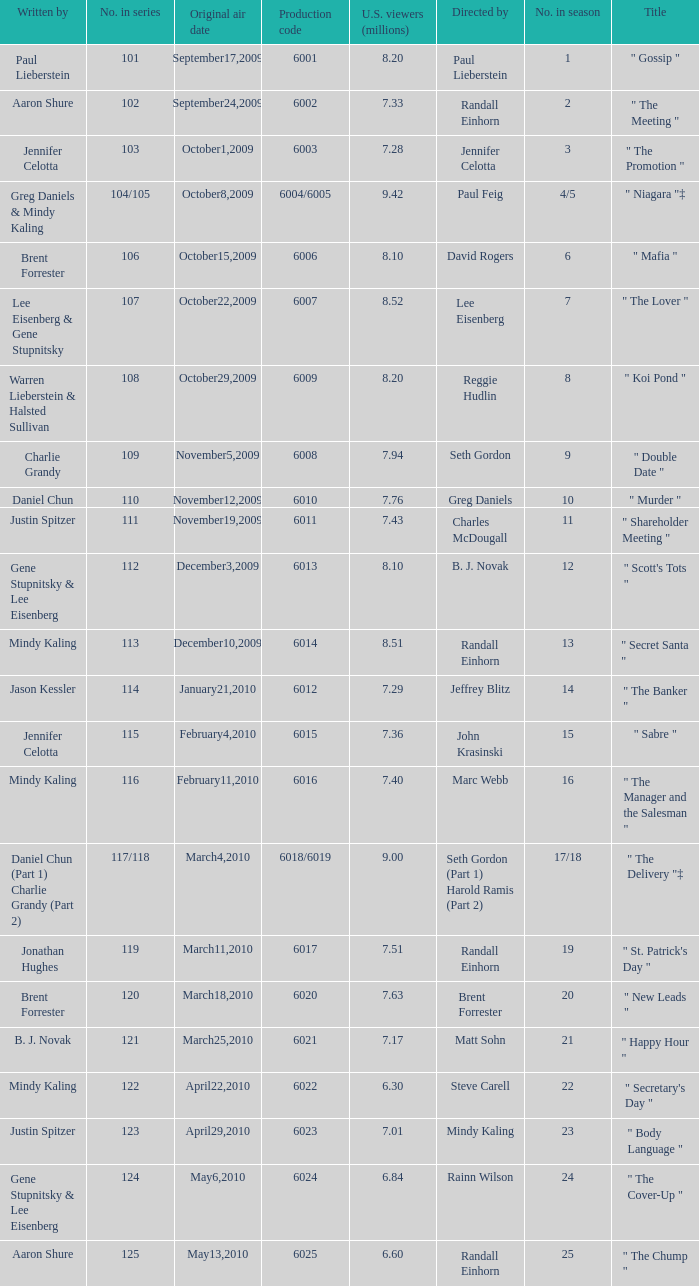Name the production code for number in season being 21 6021.0. 